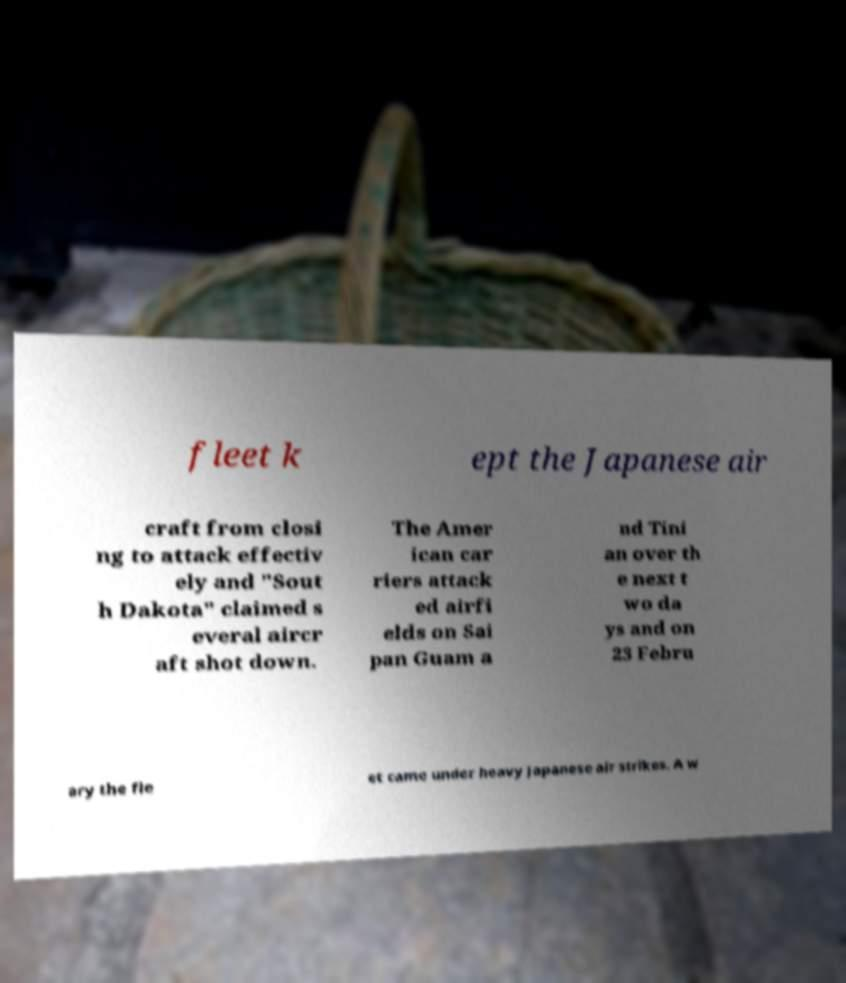Please read and relay the text visible in this image. What does it say? fleet k ept the Japanese air craft from closi ng to attack effectiv ely and "Sout h Dakota" claimed s everal aircr aft shot down. The Amer ican car riers attack ed airfi elds on Sai pan Guam a nd Tini an over th e next t wo da ys and on 23 Febru ary the fle et came under heavy Japanese air strikes. A w 